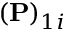Convert formula to latex. <formula><loc_0><loc_0><loc_500><loc_500>( P ) _ { 1 i }</formula> 